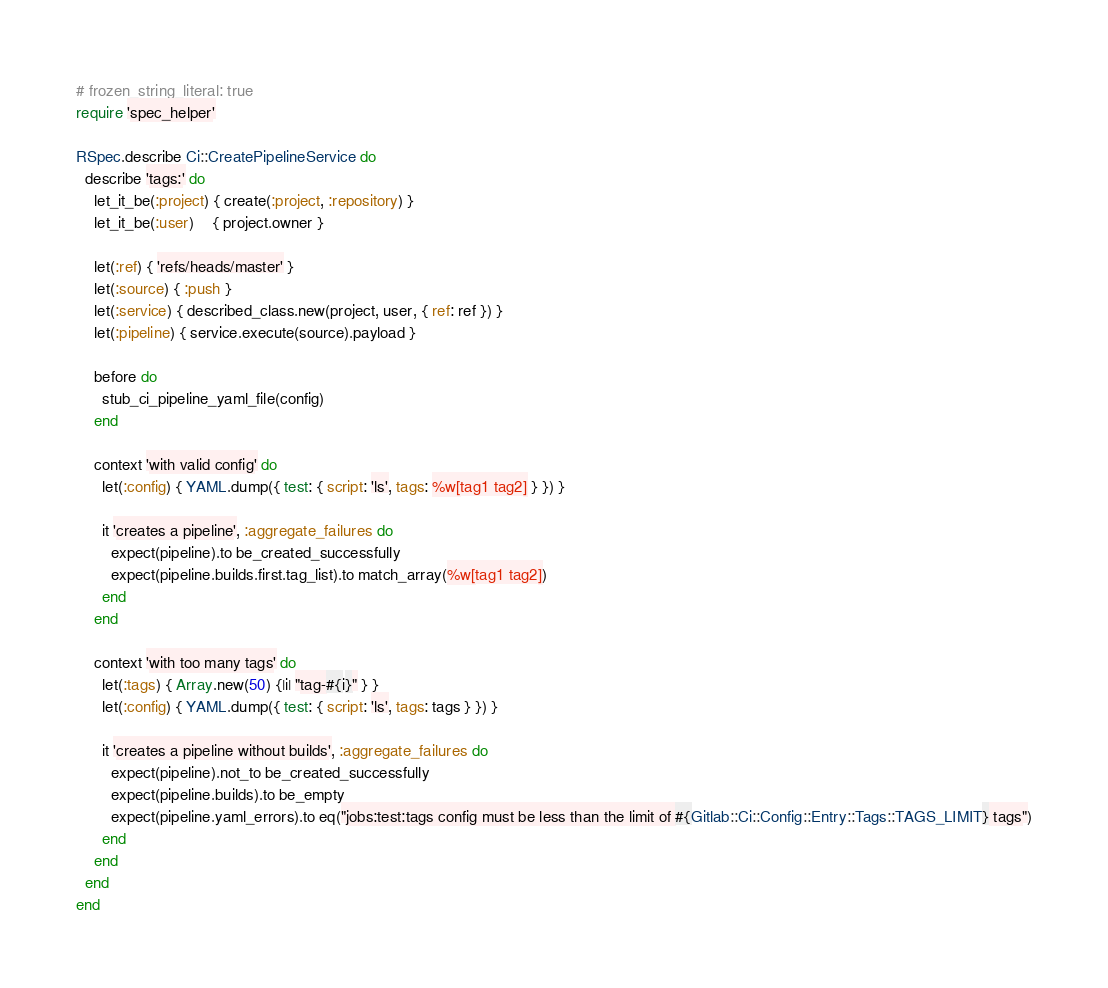<code> <loc_0><loc_0><loc_500><loc_500><_Ruby_># frozen_string_literal: true
require 'spec_helper'

RSpec.describe Ci::CreatePipelineService do
  describe 'tags:' do
    let_it_be(:project) { create(:project, :repository) }
    let_it_be(:user)    { project.owner }

    let(:ref) { 'refs/heads/master' }
    let(:source) { :push }
    let(:service) { described_class.new(project, user, { ref: ref }) }
    let(:pipeline) { service.execute(source).payload }

    before do
      stub_ci_pipeline_yaml_file(config)
    end

    context 'with valid config' do
      let(:config) { YAML.dump({ test: { script: 'ls', tags: %w[tag1 tag2] } }) }

      it 'creates a pipeline', :aggregate_failures do
        expect(pipeline).to be_created_successfully
        expect(pipeline.builds.first.tag_list).to match_array(%w[tag1 tag2])
      end
    end

    context 'with too many tags' do
      let(:tags) { Array.new(50) {|i| "tag-#{i}" } }
      let(:config) { YAML.dump({ test: { script: 'ls', tags: tags } }) }

      it 'creates a pipeline without builds', :aggregate_failures do
        expect(pipeline).not_to be_created_successfully
        expect(pipeline.builds).to be_empty
        expect(pipeline.yaml_errors).to eq("jobs:test:tags config must be less than the limit of #{Gitlab::Ci::Config::Entry::Tags::TAGS_LIMIT} tags")
      end
    end
  end
end
</code> 